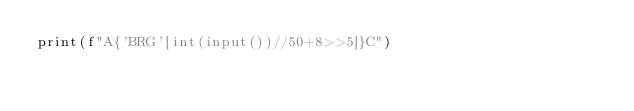<code> <loc_0><loc_0><loc_500><loc_500><_Cython_>print(f"A{'BRG'[int(input())//50+8>>5]}C")</code> 